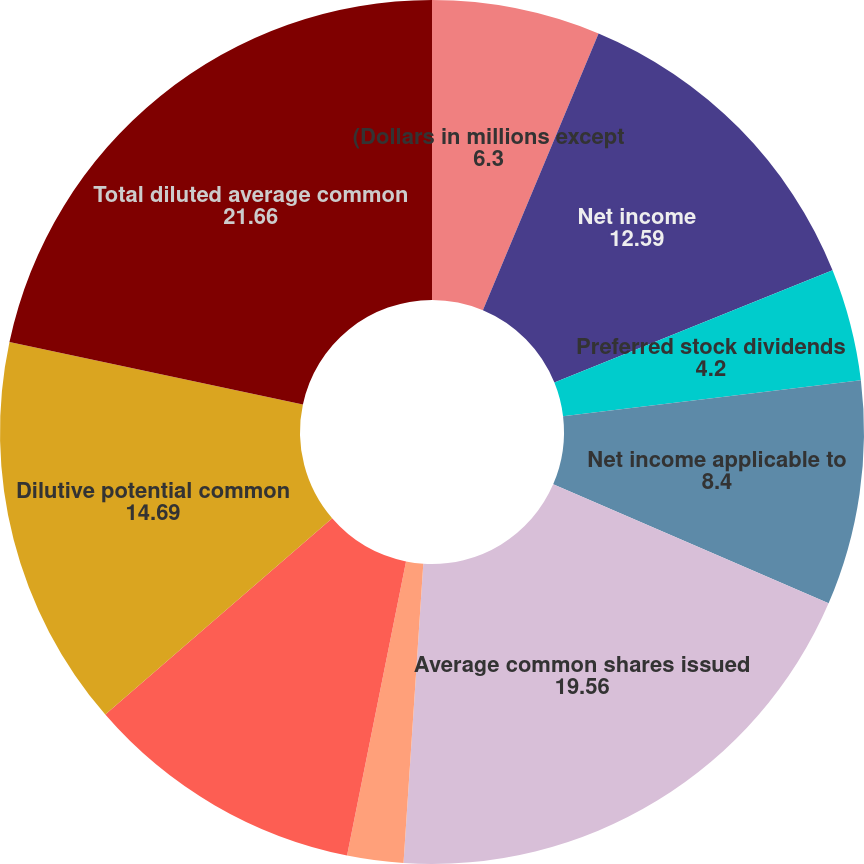Convert chart to OTSL. <chart><loc_0><loc_0><loc_500><loc_500><pie_chart><fcel>(Dollars in millions except<fcel>Net income<fcel>Preferred stock dividends<fcel>Net income applicable to<fcel>Average common shares issued<fcel>Earnings per common share<fcel>Net income allocated to common<fcel>Dilutive potential common<fcel>Total diluted average common<fcel>Diluted earnings per common<nl><fcel>6.3%<fcel>12.59%<fcel>4.2%<fcel>8.4%<fcel>19.56%<fcel>2.1%<fcel>10.5%<fcel>14.69%<fcel>21.66%<fcel>0.0%<nl></chart> 